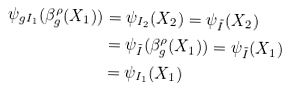<formula> <loc_0><loc_0><loc_500><loc_500>\psi _ { g I _ { 1 } } ( \beta ^ { \rho } _ { g } ( X _ { 1 } ) ) & = \psi _ { I _ { 2 } } ( X _ { 2 } ) = \psi _ { \tilde { I } } ( X _ { 2 } ) \\ & = \psi _ { \tilde { I } } ( \beta ^ { \rho } _ { g } ( X _ { 1 } ) ) = \psi _ { \tilde { I } } ( X _ { 1 } ) \\ & = \psi _ { I _ { 1 } } ( X _ { 1 } )</formula> 